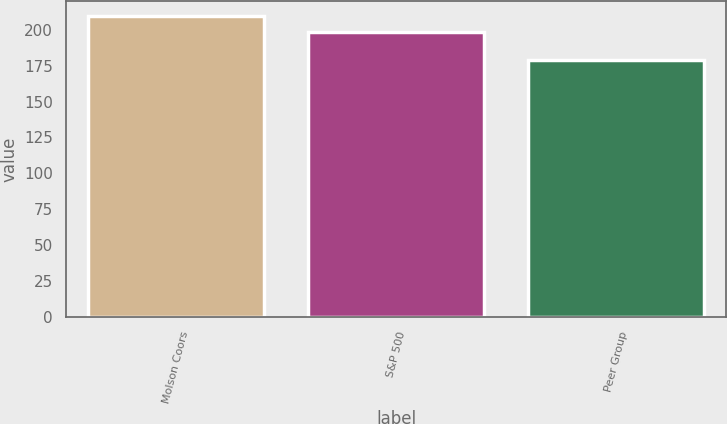<chart> <loc_0><loc_0><loc_500><loc_500><bar_chart><fcel>Molson Coors<fcel>S&P 500<fcel>Peer Group<nl><fcel>209.27<fcel>198.53<fcel>178.93<nl></chart> 